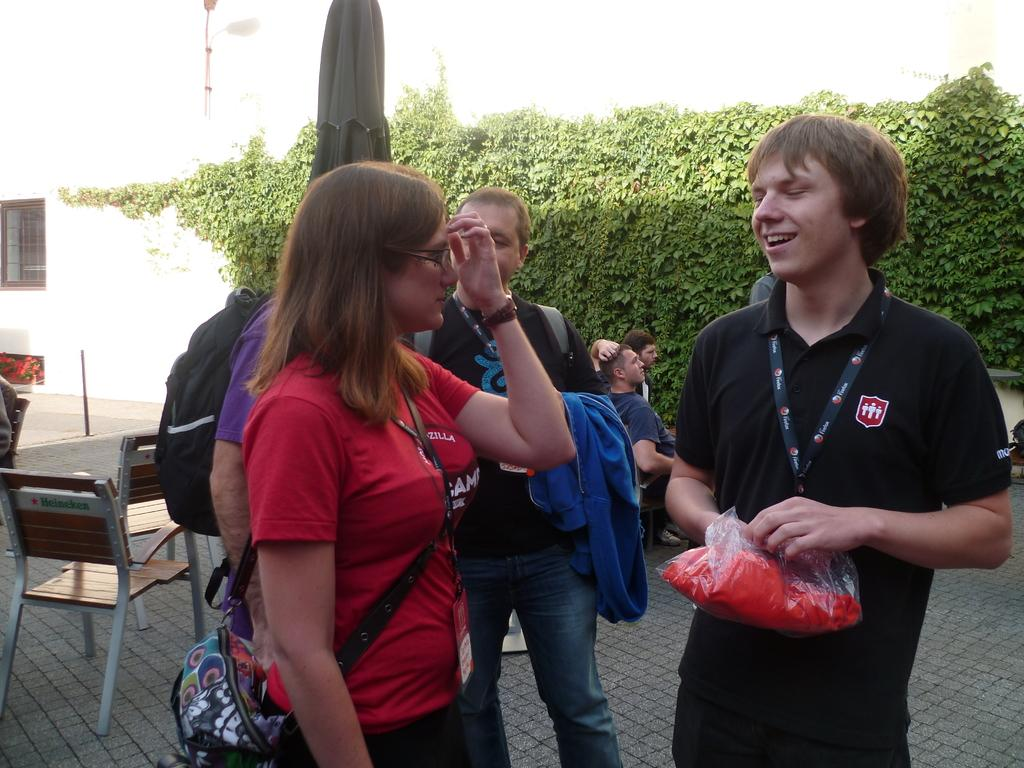How many people are in the image? There is a group of persons in the image, but the exact number is not specified. What is the position of the persons in the image? The persons are standing on the floor. What can be seen in the background of the image? Trees and buildings are visible at the top of the image. What type of print can be seen on the playground equipment in the image? There is no playground equipment present in the image, so it is not possible to determine if there is any print on it. 